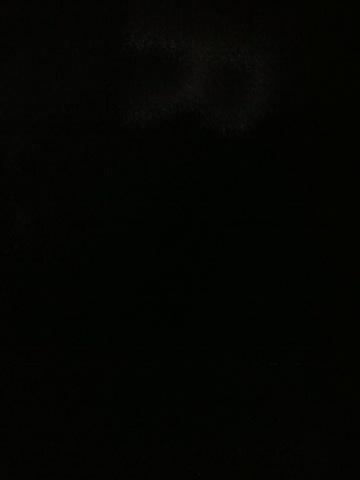Generate a short story based on this dark image. Jessica stood at the entrance of the ancient cave, her flashlight flickering against the impenetrable darkness ahead. Each step echoed, a whisper of the past. The cave was said to hold secrets of a long-lost civilization, now buried under layers of time. Her heart raced not from fear, but from the thrill of discovery. In this darkness, she felt the presence of history, waiting to share its secrets with those who dared to seek. 